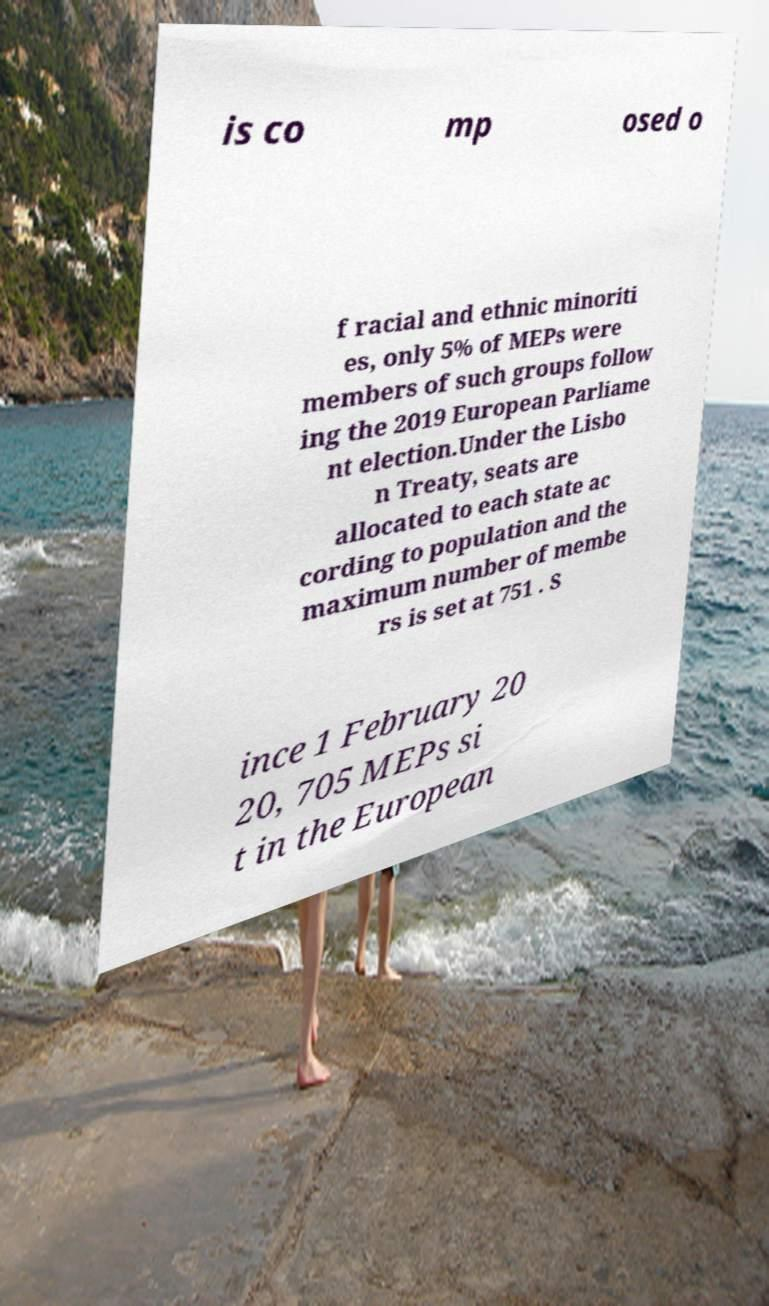There's text embedded in this image that I need extracted. Can you transcribe it verbatim? is co mp osed o f racial and ethnic minoriti es, only 5% of MEPs were members of such groups follow ing the 2019 European Parliame nt election.Under the Lisbo n Treaty, seats are allocated to each state ac cording to population and the maximum number of membe rs is set at 751 . S ince 1 February 20 20, 705 MEPs si t in the European 